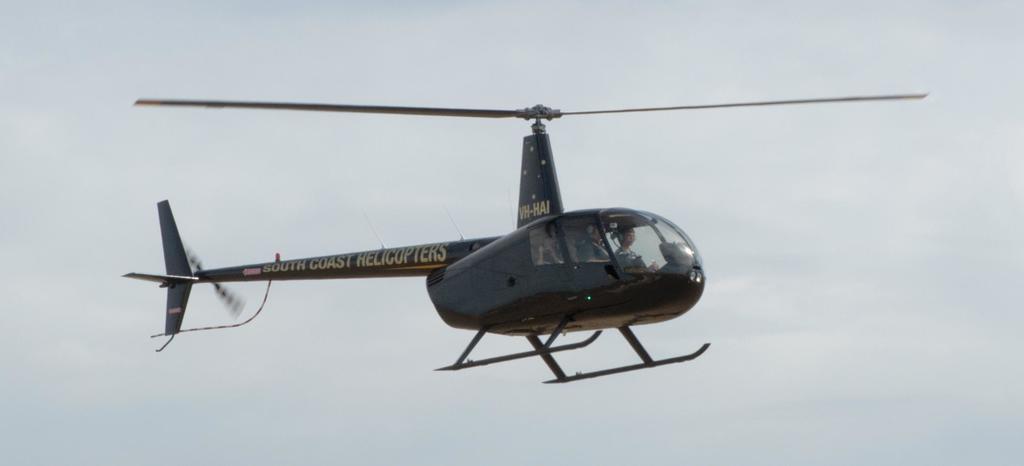How would you summarize this image in a sentence or two? This image consists of a helicopter in black color. It is flying in the air. In which we can see two persons. In the background, there is sky. 